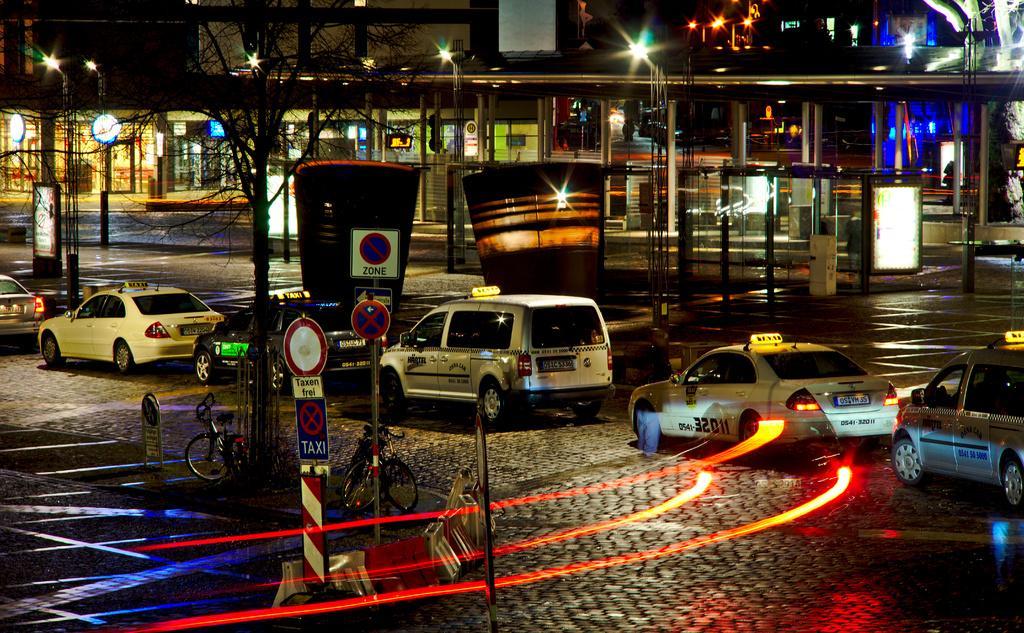Could you give a brief overview of what you see in this image? In this image, we can see vehicles on the road. At the bottom, we can see poles, sign boards, tree, bicycles and rods on the platform. Background we can see pillars, shed, lights. 